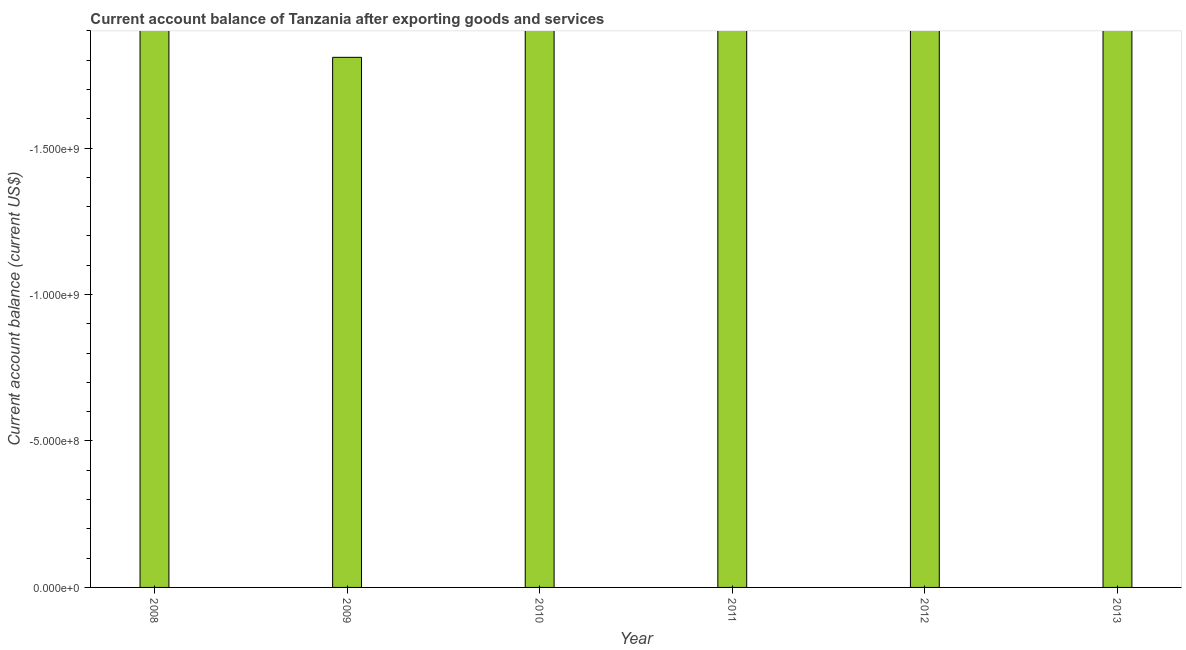Does the graph contain grids?
Provide a succinct answer. No. What is the title of the graph?
Provide a succinct answer. Current account balance of Tanzania after exporting goods and services. What is the label or title of the X-axis?
Your response must be concise. Year. What is the label or title of the Y-axis?
Your answer should be very brief. Current account balance (current US$). Across all years, what is the minimum current account balance?
Provide a succinct answer. 0. What is the sum of the current account balance?
Offer a terse response. 0. What is the median current account balance?
Give a very brief answer. 0. In how many years, is the current account balance greater than -1800000000 US$?
Make the answer very short. 0. In how many years, is the current account balance greater than the average current account balance taken over all years?
Your answer should be very brief. 0. What is the difference between two consecutive major ticks on the Y-axis?
Offer a terse response. 5.00e+08. What is the Current account balance (current US$) in 2008?
Ensure brevity in your answer.  0. What is the Current account balance (current US$) in 2009?
Your response must be concise. 0. What is the Current account balance (current US$) of 2010?
Provide a succinct answer. 0. What is the Current account balance (current US$) of 2012?
Offer a very short reply. 0. 